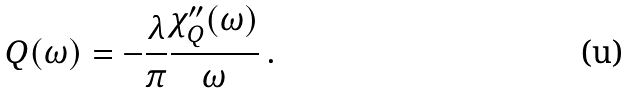<formula> <loc_0><loc_0><loc_500><loc_500>Q ( \omega ) = - \frac { \lambda } { \pi } \frac { \chi _ { Q } ^ { \prime \prime } ( \omega ) } { \omega } \, .</formula> 